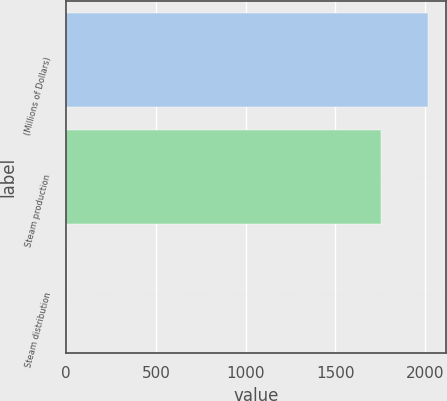Convert chart. <chart><loc_0><loc_0><loc_500><loc_500><bar_chart><fcel>(Millions of Dollars)<fcel>Steam production<fcel>Steam distribution<nl><fcel>2014<fcel>1752<fcel>6<nl></chart> 